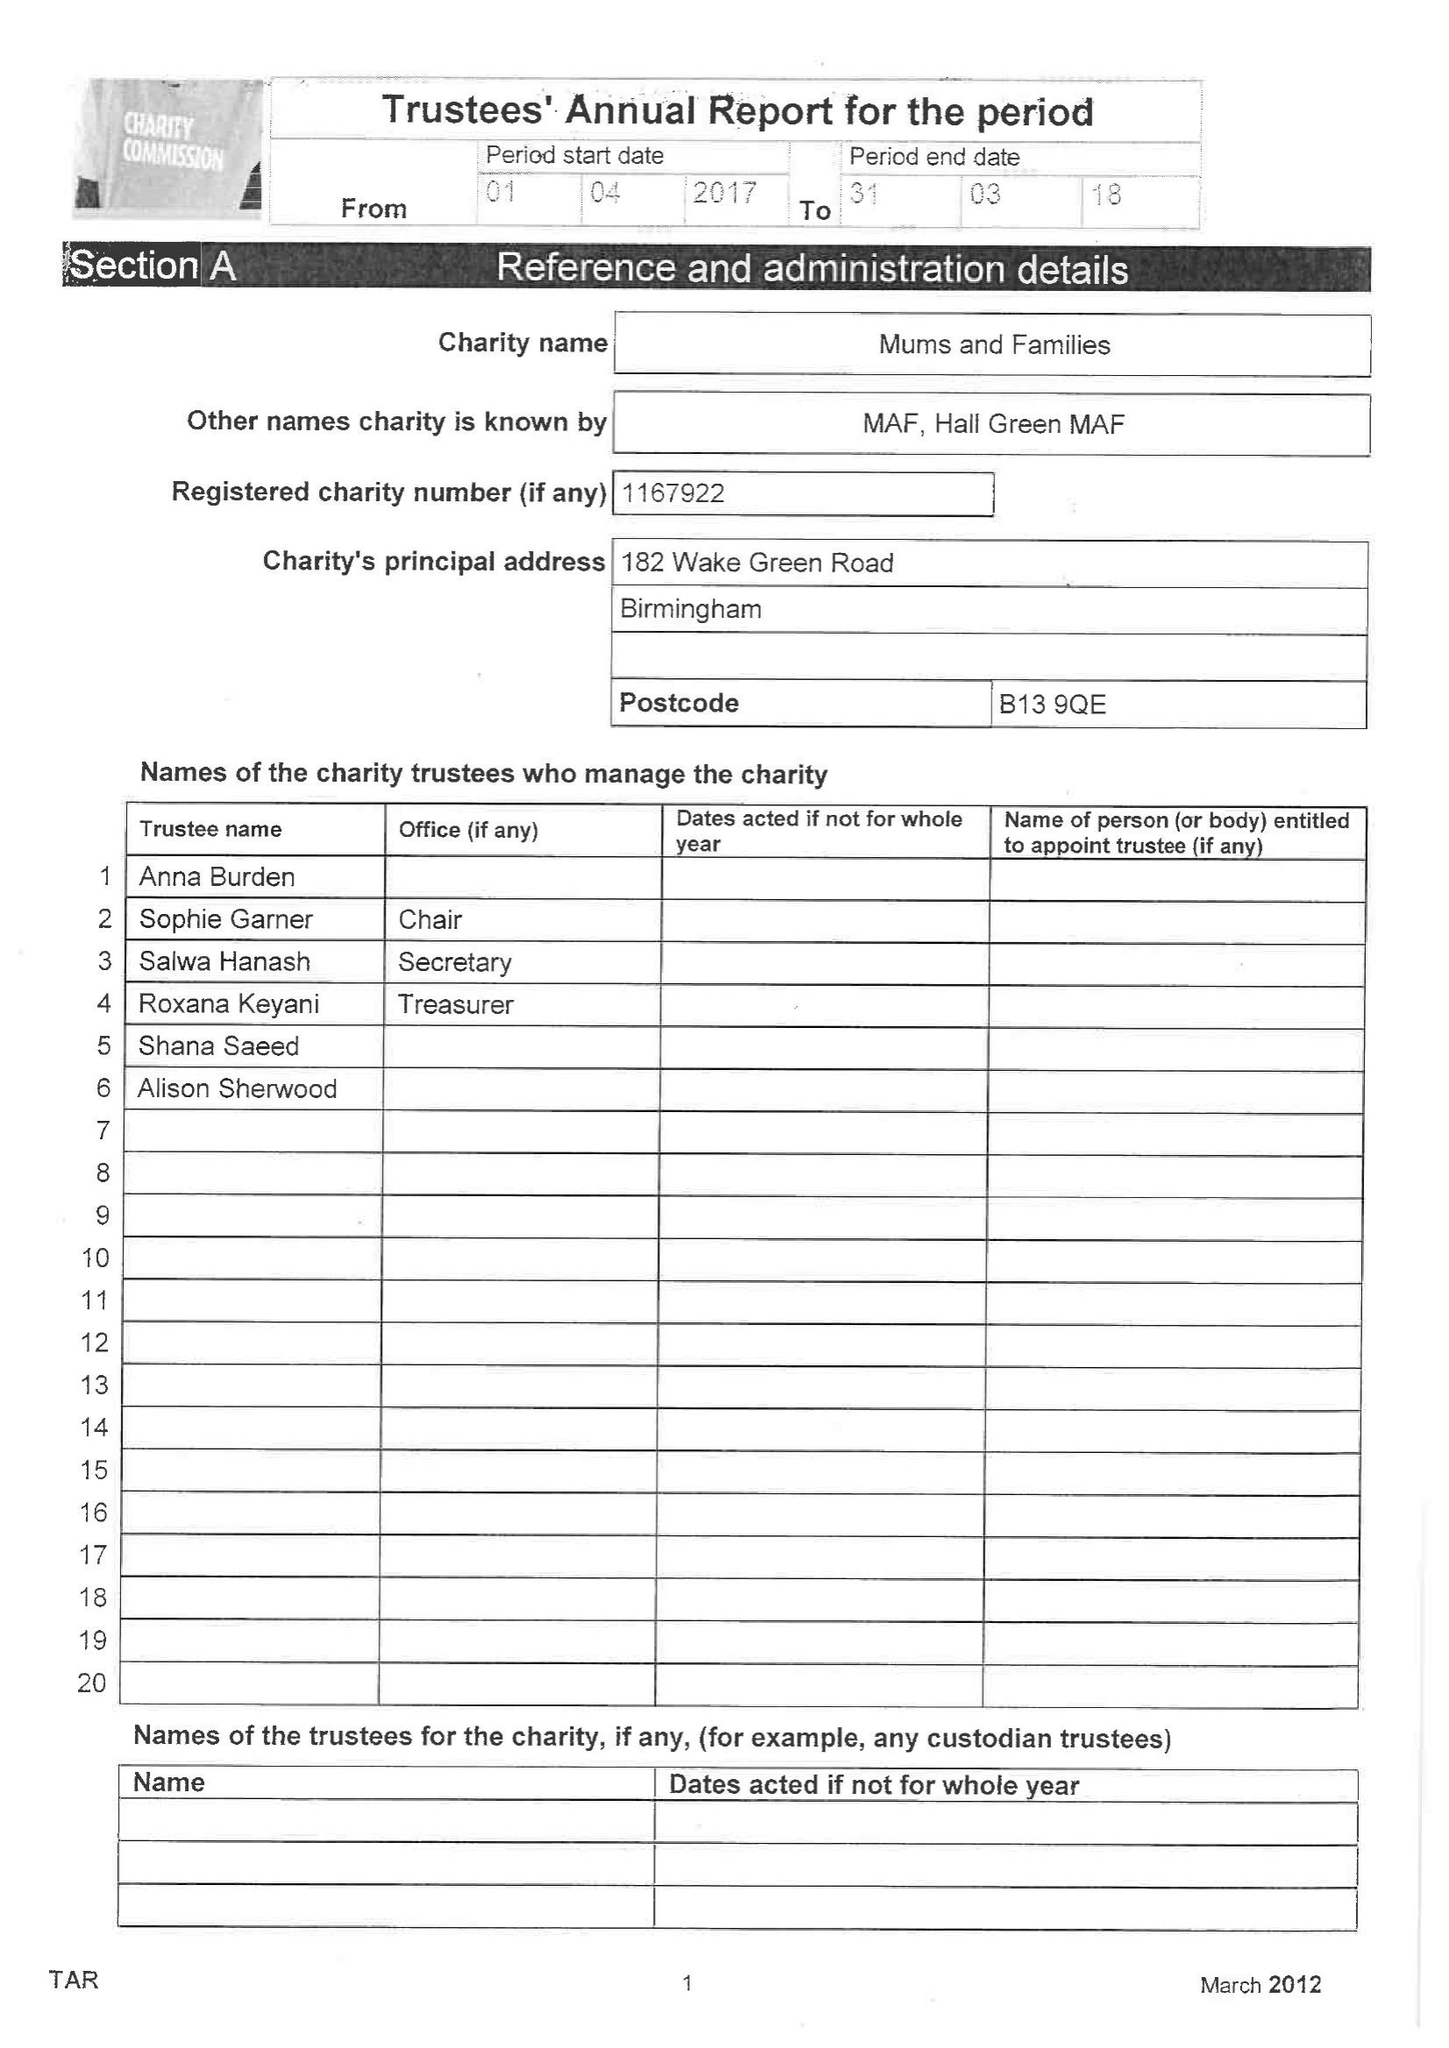What is the value for the address__postcode?
Answer the question using a single word or phrase. B13 9QE 